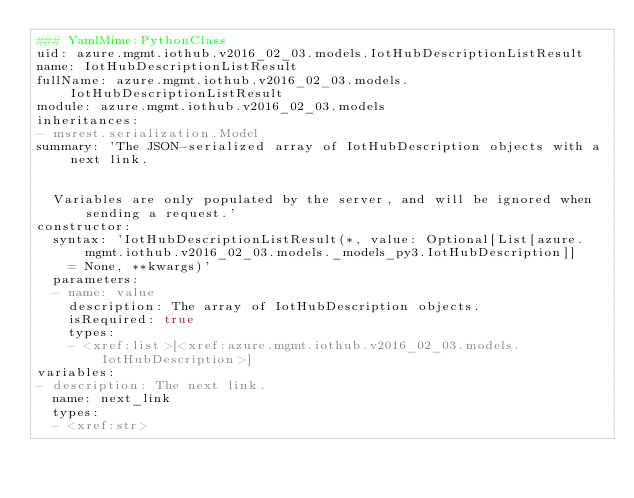<code> <loc_0><loc_0><loc_500><loc_500><_YAML_>### YamlMime:PythonClass
uid: azure.mgmt.iothub.v2016_02_03.models.IotHubDescriptionListResult
name: IotHubDescriptionListResult
fullName: azure.mgmt.iothub.v2016_02_03.models.IotHubDescriptionListResult
module: azure.mgmt.iothub.v2016_02_03.models
inheritances:
- msrest.serialization.Model
summary: 'The JSON-serialized array of IotHubDescription objects with a next link.


  Variables are only populated by the server, and will be ignored when sending a request.'
constructor:
  syntax: 'IotHubDescriptionListResult(*, value: Optional[List[azure.mgmt.iothub.v2016_02_03.models._models_py3.IotHubDescription]]
    = None, **kwargs)'
  parameters:
  - name: value
    description: The array of IotHubDescription objects.
    isRequired: true
    types:
    - <xref:list>[<xref:azure.mgmt.iothub.v2016_02_03.models.IotHubDescription>]
variables:
- description: The next link.
  name: next_link
  types:
  - <xref:str>
</code> 